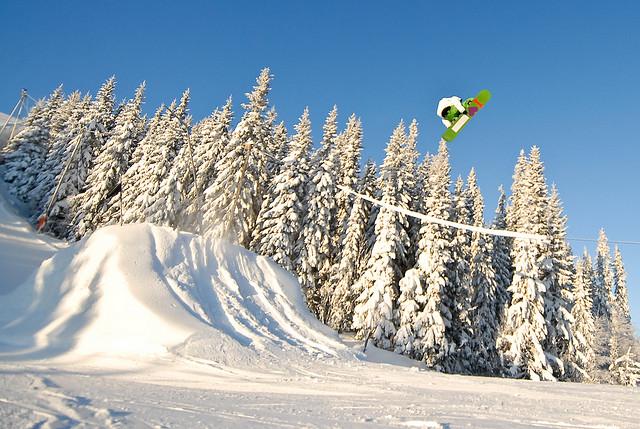What is covering the trees?
Short answer required. Snow. What is in the air?
Short answer required. Snowboarder. What is on the ground?
Be succinct. Snow. 